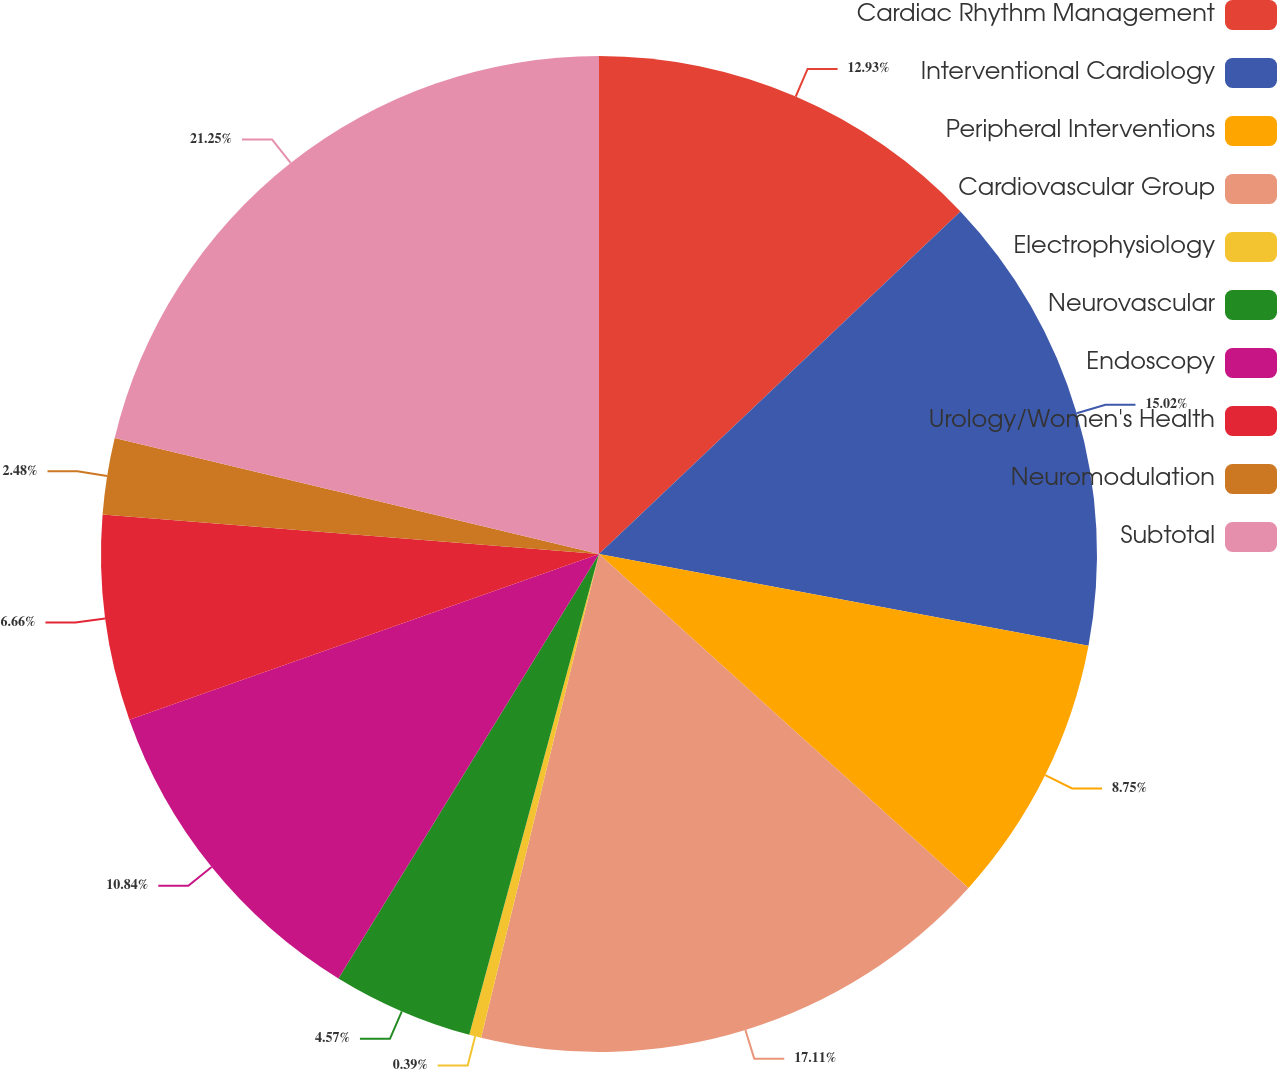<chart> <loc_0><loc_0><loc_500><loc_500><pie_chart><fcel>Cardiac Rhythm Management<fcel>Interventional Cardiology<fcel>Peripheral Interventions<fcel>Cardiovascular Group<fcel>Electrophysiology<fcel>Neurovascular<fcel>Endoscopy<fcel>Urology/Women's Health<fcel>Neuromodulation<fcel>Subtotal<nl><fcel>12.93%<fcel>15.02%<fcel>8.75%<fcel>17.11%<fcel>0.39%<fcel>4.57%<fcel>10.84%<fcel>6.66%<fcel>2.48%<fcel>21.26%<nl></chart> 